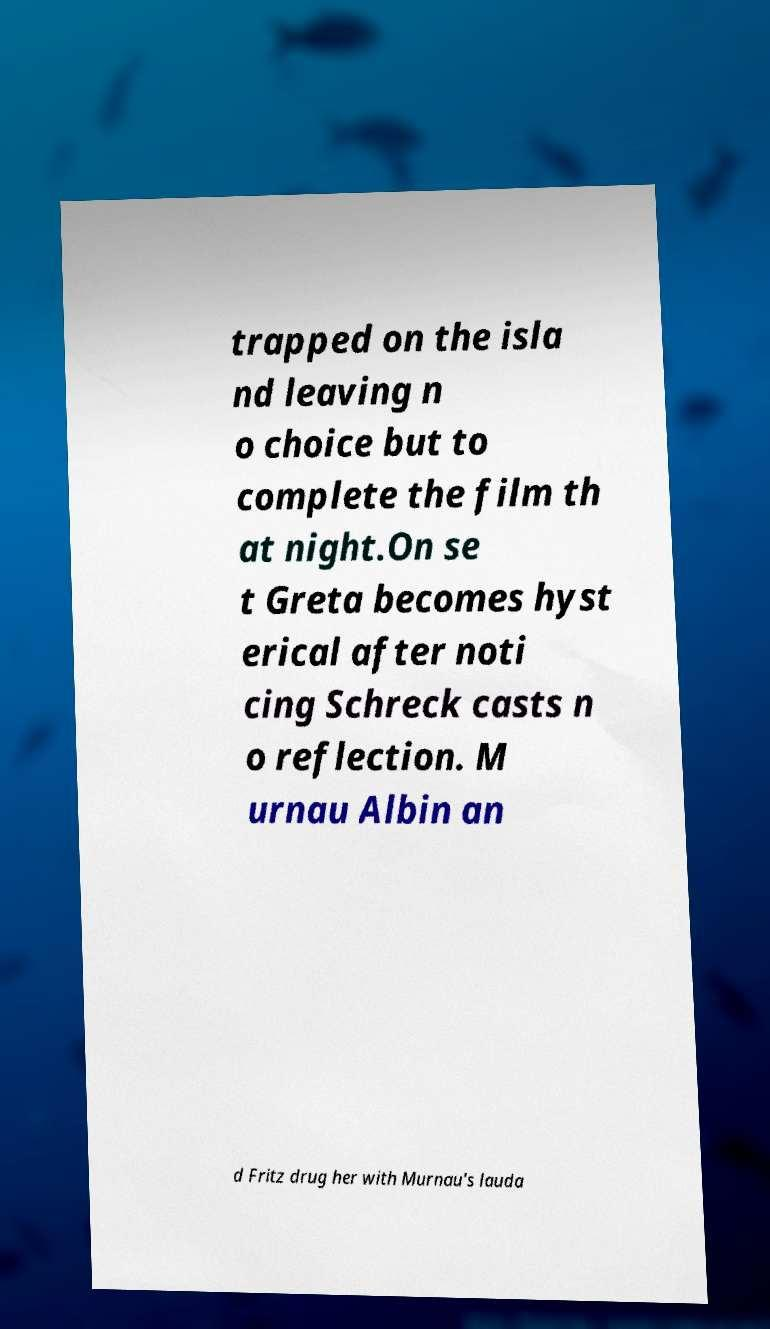Can you accurately transcribe the text from the provided image for me? trapped on the isla nd leaving n o choice but to complete the film th at night.On se t Greta becomes hyst erical after noti cing Schreck casts n o reflection. M urnau Albin an d Fritz drug her with Murnau's lauda 